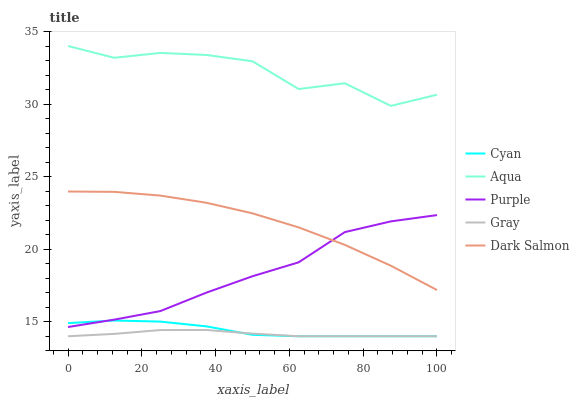Does Gray have the minimum area under the curve?
Answer yes or no. Yes. Does Aqua have the maximum area under the curve?
Answer yes or no. Yes. Does Cyan have the minimum area under the curve?
Answer yes or no. No. Does Cyan have the maximum area under the curve?
Answer yes or no. No. Is Gray the smoothest?
Answer yes or no. Yes. Is Aqua the roughest?
Answer yes or no. Yes. Is Cyan the smoothest?
Answer yes or no. No. Is Cyan the roughest?
Answer yes or no. No. Does Cyan have the lowest value?
Answer yes or no. Yes. Does Aqua have the lowest value?
Answer yes or no. No. Does Aqua have the highest value?
Answer yes or no. Yes. Does Cyan have the highest value?
Answer yes or no. No. Is Cyan less than Dark Salmon?
Answer yes or no. Yes. Is Aqua greater than Purple?
Answer yes or no. Yes. Does Cyan intersect Gray?
Answer yes or no. Yes. Is Cyan less than Gray?
Answer yes or no. No. Is Cyan greater than Gray?
Answer yes or no. No. Does Cyan intersect Dark Salmon?
Answer yes or no. No. 